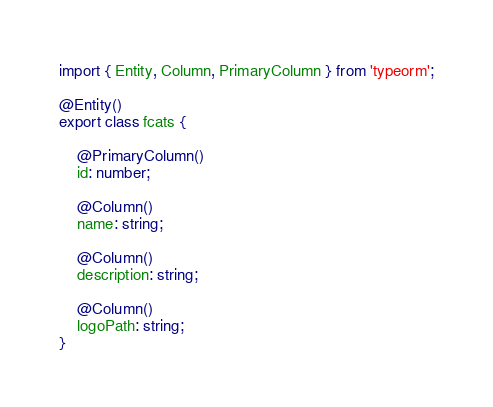Convert code to text. <code><loc_0><loc_0><loc_500><loc_500><_TypeScript_>import { Entity, Column, PrimaryColumn } from 'typeorm';

@Entity()
export class fcats {

    @PrimaryColumn()
    id: number;

    @Column()
    name: string;

    @Column()
    description: string;

    @Column()
    logoPath: string;
}
</code> 